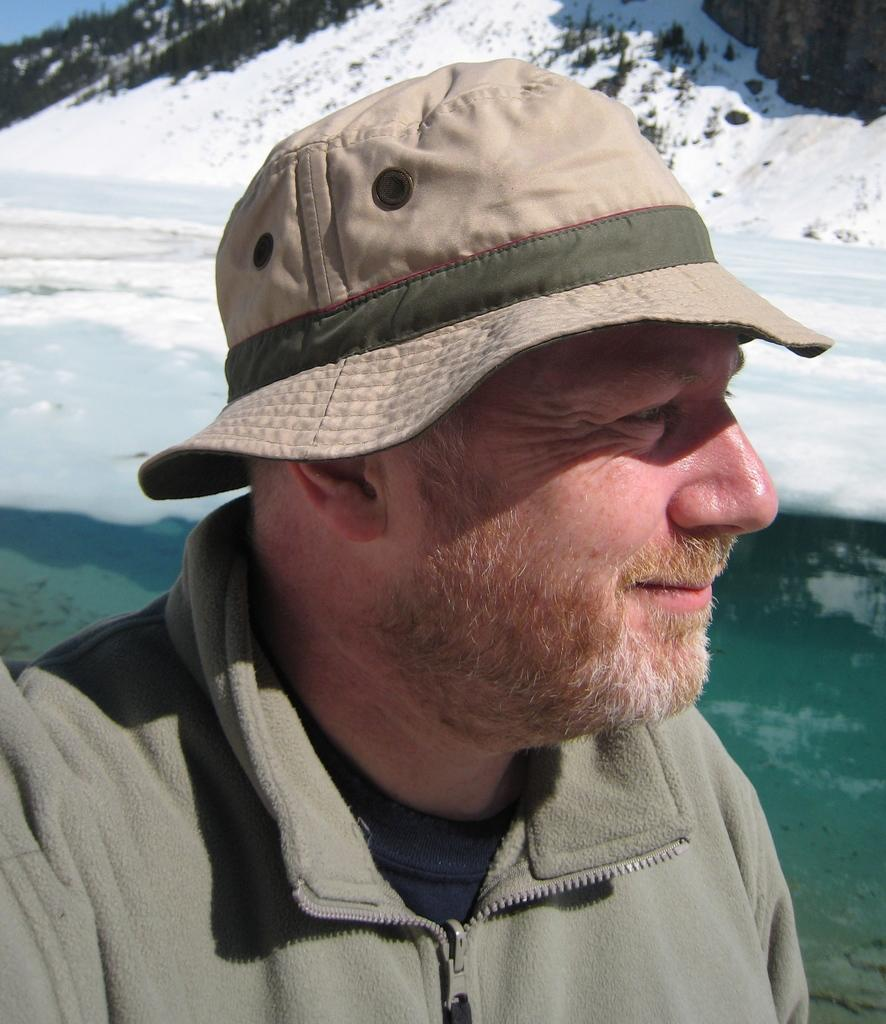Who is present in the image? There is a man in the image. What is the man's facial expression? The man is smiling. What is the setting of the image? The image depicts snow. What can be seen in the background of the image? There are trees and the sky visible in the background of the image. What type of star can be seen in the image? There is no star visible in the image; it depicts a snowy scene with a man and trees in the background. 